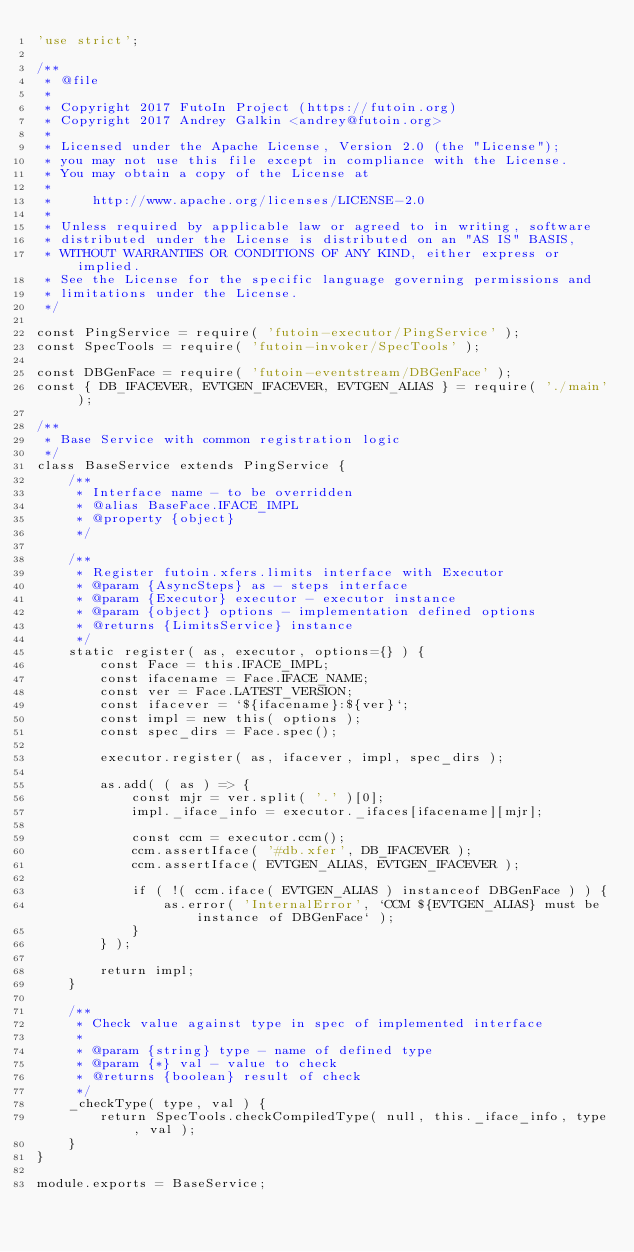Convert code to text. <code><loc_0><loc_0><loc_500><loc_500><_JavaScript_>'use strict';

/**
 * @file
 *
 * Copyright 2017 FutoIn Project (https://futoin.org)
 * Copyright 2017 Andrey Galkin <andrey@futoin.org>
 *
 * Licensed under the Apache License, Version 2.0 (the "License");
 * you may not use this file except in compliance with the License.
 * You may obtain a copy of the License at
 *
 *     http://www.apache.org/licenses/LICENSE-2.0
 *
 * Unless required by applicable law or agreed to in writing, software
 * distributed under the License is distributed on an "AS IS" BASIS,
 * WITHOUT WARRANTIES OR CONDITIONS OF ANY KIND, either express or implied.
 * See the License for the specific language governing permissions and
 * limitations under the License.
 */

const PingService = require( 'futoin-executor/PingService' );
const SpecTools = require( 'futoin-invoker/SpecTools' );

const DBGenFace = require( 'futoin-eventstream/DBGenFace' );
const { DB_IFACEVER, EVTGEN_IFACEVER, EVTGEN_ALIAS } = require( './main' );

/**
 * Base Service with common registration logic
 */
class BaseService extends PingService {
    /**
     * Interface name - to be overridden
     * @alias BaseFace.IFACE_IMPL
     * @property {object}
     */

    /**
     * Register futoin.xfers.limits interface with Executor
     * @param {AsyncSteps} as - steps interface
     * @param {Executor} executor - executor instance
     * @param {object} options - implementation defined options
     * @returns {LimitsService} instance
     */
    static register( as, executor, options={} ) {
        const Face = this.IFACE_IMPL;
        const ifacename = Face.IFACE_NAME;
        const ver = Face.LATEST_VERSION;
        const ifacever = `${ifacename}:${ver}`;
        const impl = new this( options );
        const spec_dirs = Face.spec();

        executor.register( as, ifacever, impl, spec_dirs );

        as.add( ( as ) => {
            const mjr = ver.split( '.' )[0];
            impl._iface_info = executor._ifaces[ifacename][mjr];

            const ccm = executor.ccm();
            ccm.assertIface( '#db.xfer', DB_IFACEVER );
            ccm.assertIface( EVTGEN_ALIAS, EVTGEN_IFACEVER );

            if ( !( ccm.iface( EVTGEN_ALIAS ) instanceof DBGenFace ) ) {
                as.error( 'InternalError', `CCM ${EVTGEN_ALIAS} must be instance of DBGenFace` );
            }
        } );

        return impl;
    }

    /**
     * Check value against type in spec of implemented interface
     *
     * @param {string} type - name of defined type
     * @param {*} val - value to check
     * @returns {boolean} result of check
     */
    _checkType( type, val ) {
        return SpecTools.checkCompiledType( null, this._iface_info, type, val );
    }
}

module.exports = BaseService;
</code> 